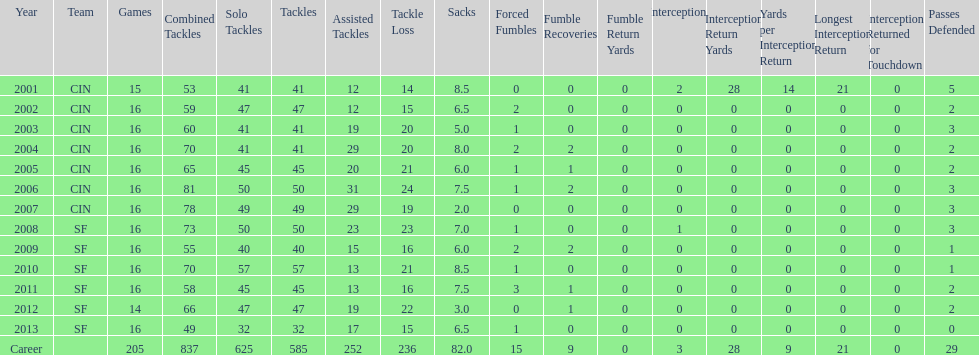What is the total number of sacks smith has made? 82.0. 